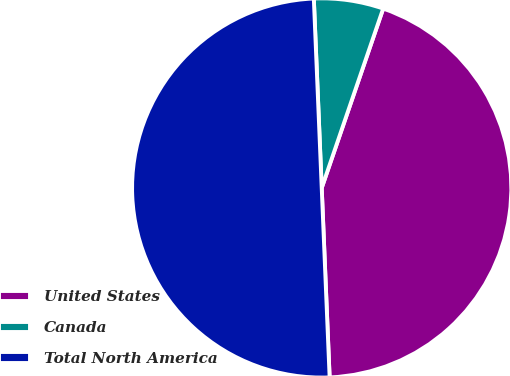Convert chart to OTSL. <chart><loc_0><loc_0><loc_500><loc_500><pie_chart><fcel>United States<fcel>Canada<fcel>Total North America<nl><fcel>44.08%<fcel>5.92%<fcel>50.0%<nl></chart> 